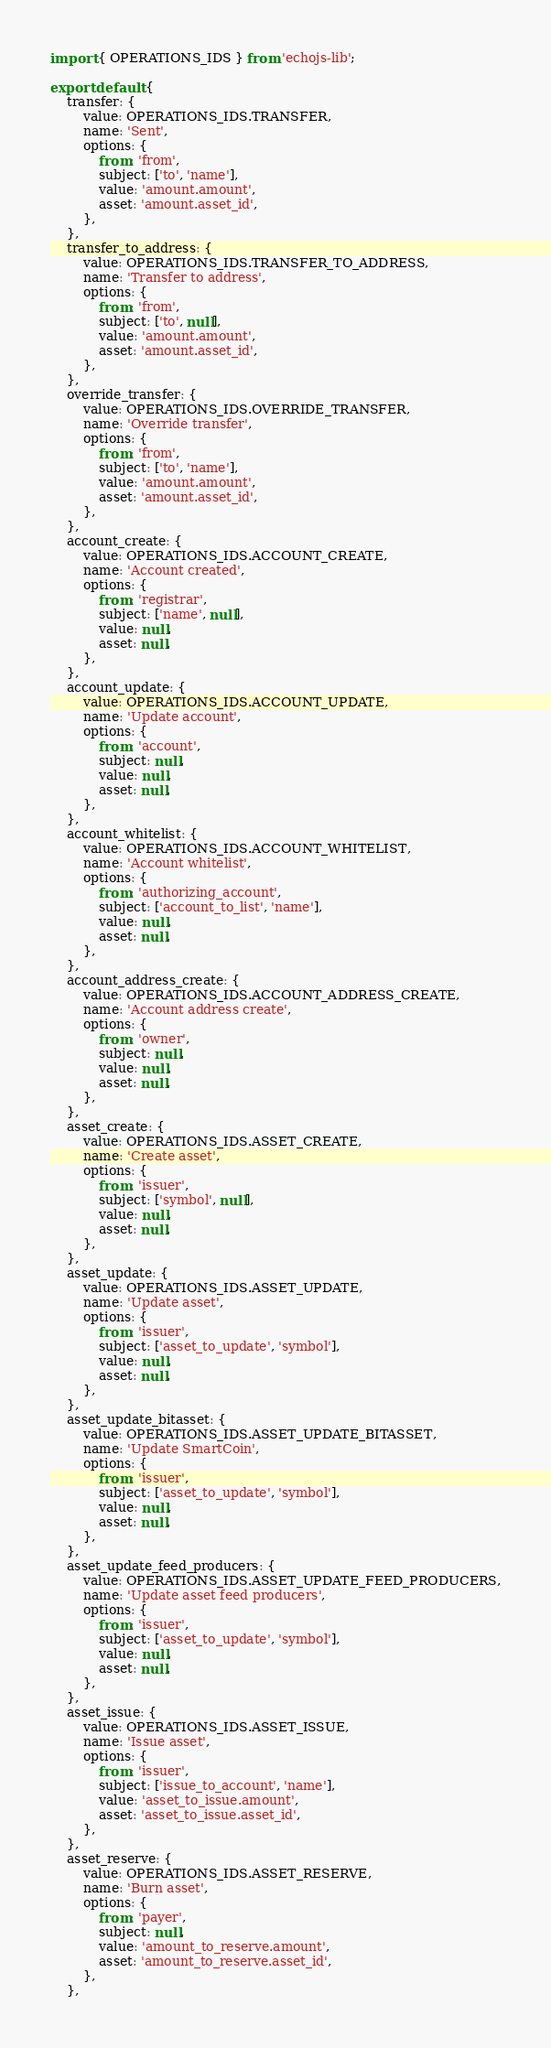Convert code to text. <code><loc_0><loc_0><loc_500><loc_500><_JavaScript_>import { OPERATIONS_IDS } from 'echojs-lib';

export default {
	transfer: {
		value: OPERATIONS_IDS.TRANSFER,
		name: 'Sent',
		options: {
			from: 'from',
			subject: ['to', 'name'],
			value: 'amount.amount',
			asset: 'amount.asset_id',
		},
	},
	transfer_to_address: {
		value: OPERATIONS_IDS.TRANSFER_TO_ADDRESS,
		name: 'Transfer to address',
		options: {
			from: 'from',
			subject: ['to', null],
			value: 'amount.amount',
			asset: 'amount.asset_id',
		},
	},
	override_transfer: {
		value: OPERATIONS_IDS.OVERRIDE_TRANSFER,
		name: 'Override transfer',
		options: {
			from: 'from',
			subject: ['to', 'name'],
			value: 'amount.amount',
			asset: 'amount.asset_id',
		},
	},
	account_create: {
		value: OPERATIONS_IDS.ACCOUNT_CREATE,
		name: 'Account created',
		options: {
			from: 'registrar',
			subject: ['name', null],
			value: null,
			asset: null,
		},
	},
	account_update: {
		value: OPERATIONS_IDS.ACCOUNT_UPDATE,
		name: 'Update account',
		options: {
			from: 'account',
			subject: null,
			value: null,
			asset: null,
		},
	},
	account_whitelist: {
		value: OPERATIONS_IDS.ACCOUNT_WHITELIST,
		name: 'Account whitelist',
		options: {
			from: 'authorizing_account',
			subject: ['account_to_list', 'name'],
			value: null,
			asset: null,
		},
	},
	account_address_create: {
		value: OPERATIONS_IDS.ACCOUNT_ADDRESS_CREATE,
		name: 'Account address create',
		options: {
			from: 'owner',
			subject: null,
			value: null,
			asset: null,
		},
	},
	asset_create: {
		value: OPERATIONS_IDS.ASSET_CREATE,
		name: 'Create asset',
		options: {
			from: 'issuer',
			subject: ['symbol', null],
			value: null,
			asset: null,
		},
	},
	asset_update: {
		value: OPERATIONS_IDS.ASSET_UPDATE,
		name: 'Update asset',
		options: {
			from: 'issuer',
			subject: ['asset_to_update', 'symbol'],
			value: null,
			asset: null,
		},
	},
	asset_update_bitasset: {
		value: OPERATIONS_IDS.ASSET_UPDATE_BITASSET,
		name: 'Update SmartCoin',
		options: {
			from: 'issuer',
			subject: ['asset_to_update', 'symbol'],
			value: null,
			asset: null,
		},
	},
	asset_update_feed_producers: {
		value: OPERATIONS_IDS.ASSET_UPDATE_FEED_PRODUCERS,
		name: 'Update asset feed producers',
		options: {
			from: 'issuer',
			subject: ['asset_to_update', 'symbol'],
			value: null,
			asset: null,
		},
	},
	asset_issue: {
		value: OPERATIONS_IDS.ASSET_ISSUE,
		name: 'Issue asset',
		options: {
			from: 'issuer',
			subject: ['issue_to_account', 'name'],
			value: 'asset_to_issue.amount',
			asset: 'asset_to_issue.asset_id',
		},
	},
	asset_reserve: {
		value: OPERATIONS_IDS.ASSET_RESERVE,
		name: 'Burn asset',
		options: {
			from: 'payer',
			subject: null,
			value: 'amount_to_reserve.amount',
			asset: 'amount_to_reserve.asset_id',
		},
	},</code> 